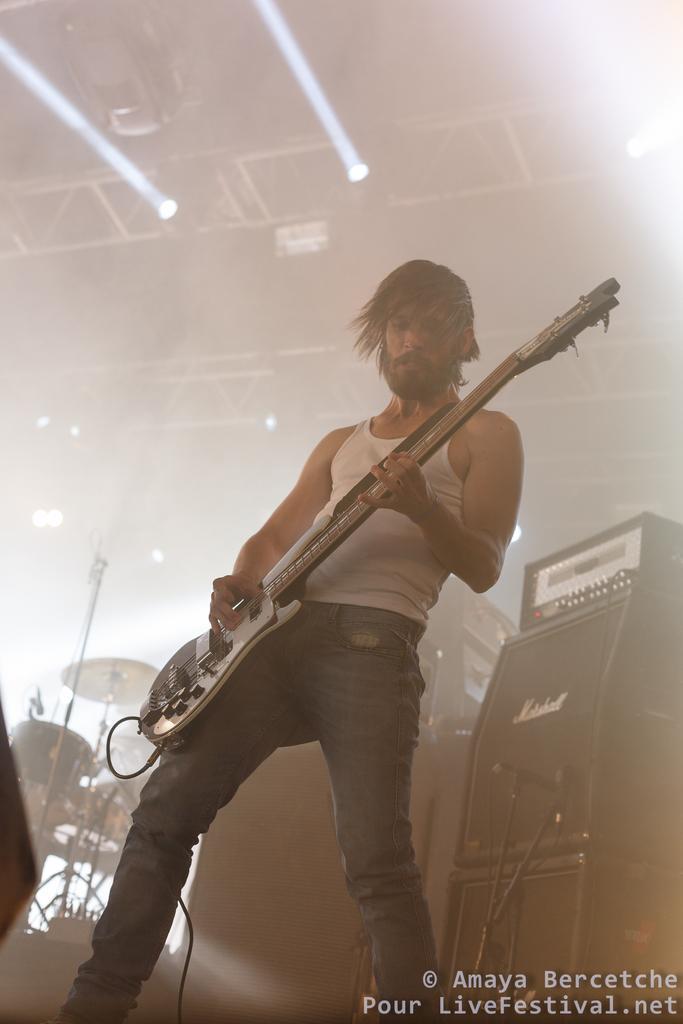Can you describe this image briefly? There is a man who is wearing vest of white color and a jeans he is holding guitar in his hands ,in the background there are few musical instruments, on the roof there are lights, to the right side of the person there are other instruments. 